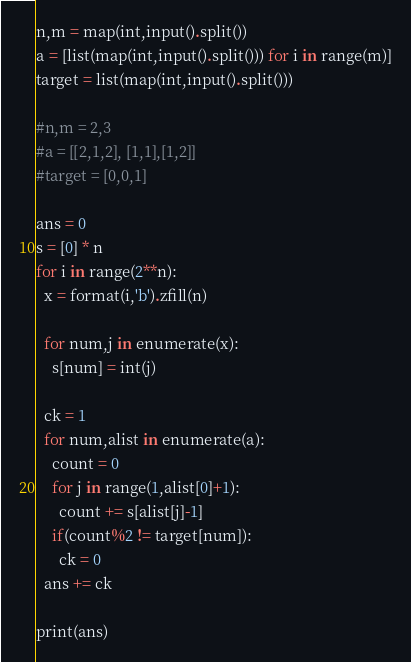Convert code to text. <code><loc_0><loc_0><loc_500><loc_500><_Python_>
n,m = map(int,input().split())
a = [list(map(int,input().split())) for i in range(m)]
target = list(map(int,input().split()))

#n,m = 2,3
#a = [[2,1,2], [1,1],[1,2]]
#target = [0,0,1]

ans = 0
s = [0] * n
for i in range(2**n):
  x = format(i,'b').zfill(n)

  for num,j in enumerate(x):
    s[num] = int(j)

  ck = 1
  for num,alist in enumerate(a):
    count = 0
    for j in range(1,alist[0]+1):
      count += s[alist[j]-1]
    if(count%2 != target[num]):
      ck = 0
  ans += ck

print(ans)</code> 